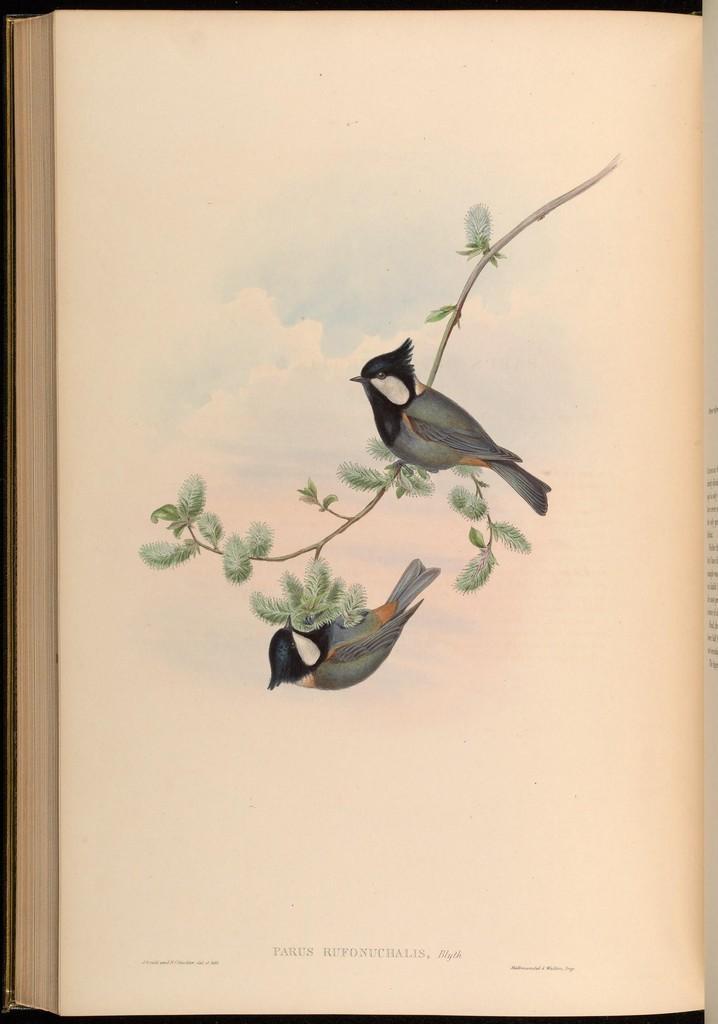Could you give a brief overview of what you see in this image? In this image we can see a book. On the page of the book we can see painting of birds and stem with leaves. Also there is text. 